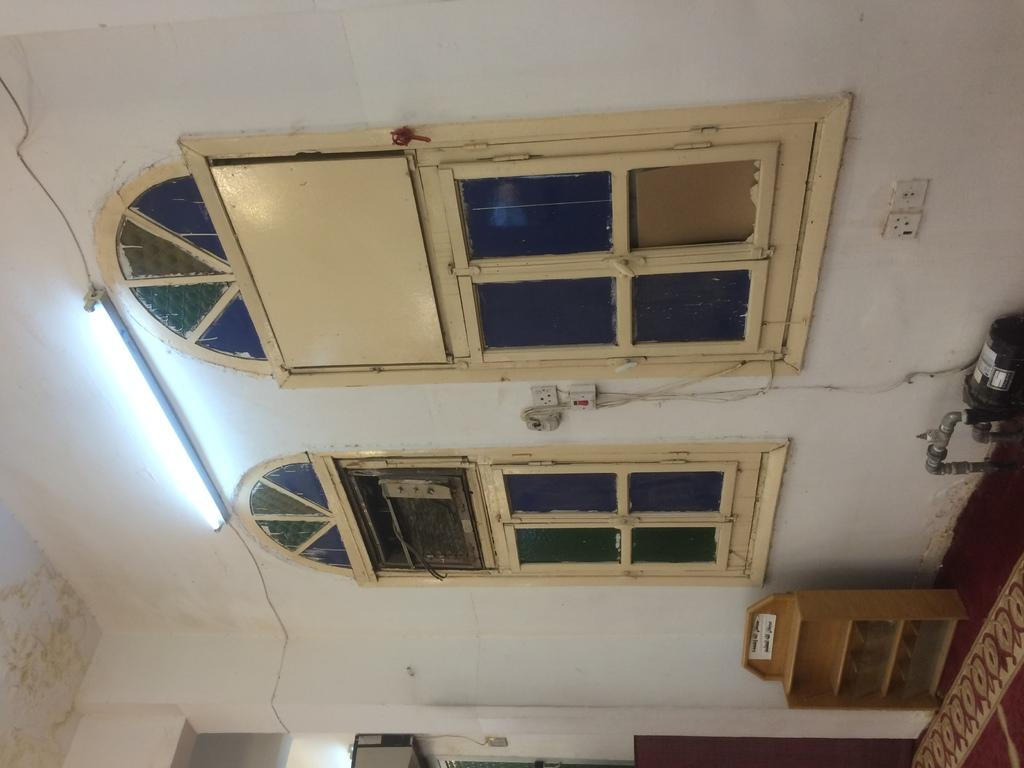What type of structure is present in the image? There is a building in the image. How many windows can be seen on the building? The building has two windows. What type of lighting is present in the image? There is one tube light in the image. How many switch boards are visible in the image? There are two switch boards in the image. What type of electrical device is present in the image? There is an electrical motor in the image. What type of material is used to make the box in the image? There is a box made of wood in the image. What type of joke is being told by the stranger in the image? There is no stranger present in the image, and therefore no joke being told. What type of curve can be seen in the image? There is no curve present in the image. 